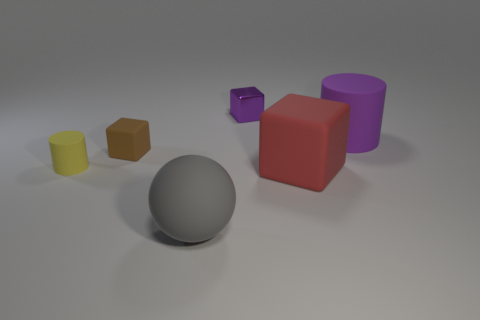The tiny matte thing that is the same shape as the large red thing is what color?
Your answer should be compact. Brown. Do the matte block that is to the right of the small purple thing and the big sphere have the same color?
Offer a very short reply. No. There is a large red rubber object; are there any big red rubber things on the left side of it?
Ensure brevity in your answer.  No. There is a matte thing that is both on the right side of the gray rubber sphere and behind the tiny yellow matte thing; what color is it?
Your response must be concise. Purple. What is the shape of the large rubber thing that is the same color as the tiny metal thing?
Provide a short and direct response. Cylinder. There is a cylinder that is left of the matte cylinder that is on the right side of the large gray sphere; how big is it?
Your response must be concise. Small. How many spheres are either gray rubber things or metallic objects?
Your answer should be compact. 1. What color is the matte cylinder that is the same size as the brown object?
Your answer should be compact. Yellow. What shape is the small rubber object on the right side of the cylinder that is left of the big ball?
Keep it short and to the point. Cube. There is a rubber cylinder that is behind the brown block; is its size the same as the large gray thing?
Your answer should be compact. Yes. 